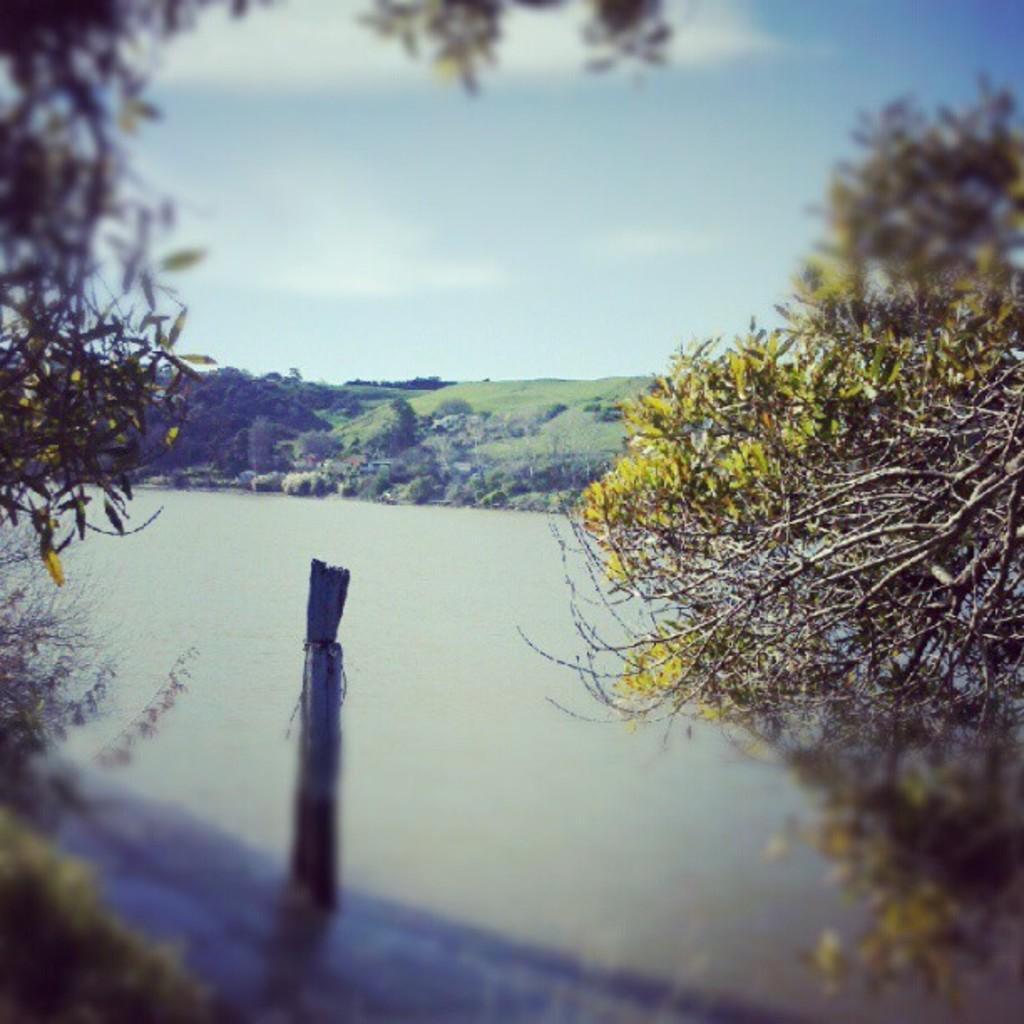How would you summarize this image in a sentence or two? In this picture we can see a river. In the background we can see the grass, mountain and tent. At the top we can see sky and clouds. On the right we can see trees. 